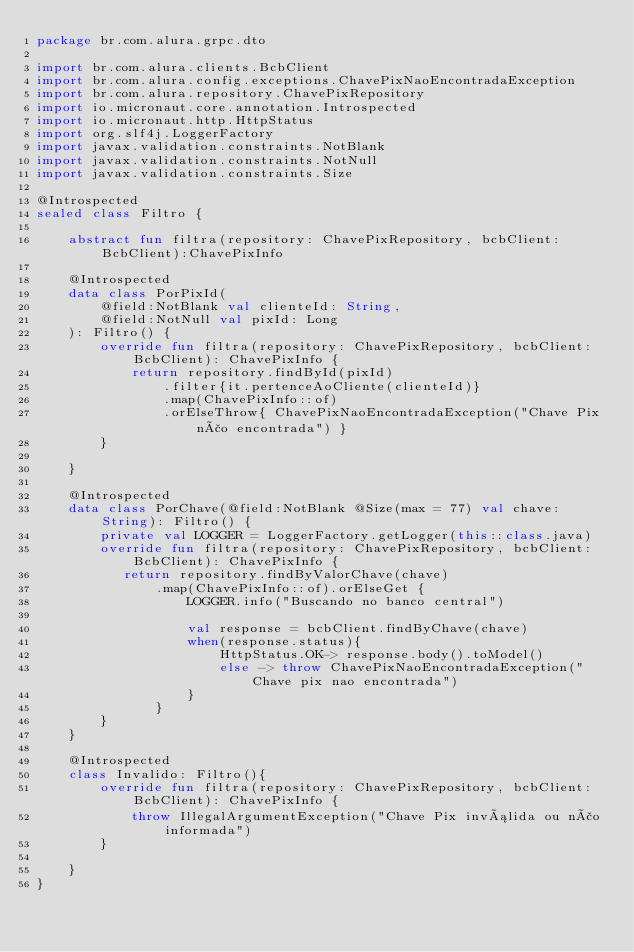<code> <loc_0><loc_0><loc_500><loc_500><_Kotlin_>package br.com.alura.grpc.dto

import br.com.alura.clients.BcbClient
import br.com.alura.config.exceptions.ChavePixNaoEncontradaException
import br.com.alura.repository.ChavePixRepository
import io.micronaut.core.annotation.Introspected
import io.micronaut.http.HttpStatus
import org.slf4j.LoggerFactory
import javax.validation.constraints.NotBlank
import javax.validation.constraints.NotNull
import javax.validation.constraints.Size

@Introspected
sealed class Filtro {

    abstract fun filtra(repository: ChavePixRepository, bcbClient: BcbClient):ChavePixInfo

    @Introspected
    data class PorPixId(
        @field:NotBlank val clienteId: String,
        @field:NotNull val pixId: Long
    ): Filtro() {
        override fun filtra(repository: ChavePixRepository, bcbClient: BcbClient): ChavePixInfo {
            return repository.findById(pixId)
                .filter{it.pertenceAoCliente(clienteId)}
                .map(ChavePixInfo::of)
                .orElseThrow{ ChavePixNaoEncontradaException("Chave Pix não encontrada") }
        }

    }

    @Introspected
    data class PorChave(@field:NotBlank @Size(max = 77) val chave: String): Filtro() {
        private val LOGGER = LoggerFactory.getLogger(this::class.java)
        override fun filtra(repository: ChavePixRepository, bcbClient: BcbClient): ChavePixInfo {
           return repository.findByValorChave(chave)
               .map(ChavePixInfo::of).orElseGet {
                   LOGGER.info("Buscando no banco central")

                   val response = bcbClient.findByChave(chave)
                   when(response.status){
                       HttpStatus.OK-> response.body().toModel()
                       else -> throw ChavePixNaoEncontradaException("Chave pix nao encontrada")
                   }
               }
        }
    }

    @Introspected
    class Invalido: Filtro(){
        override fun filtra(repository: ChavePixRepository, bcbClient: BcbClient): ChavePixInfo {
            throw IllegalArgumentException("Chave Pix inválida ou não informada")
        }

    }
}
</code> 